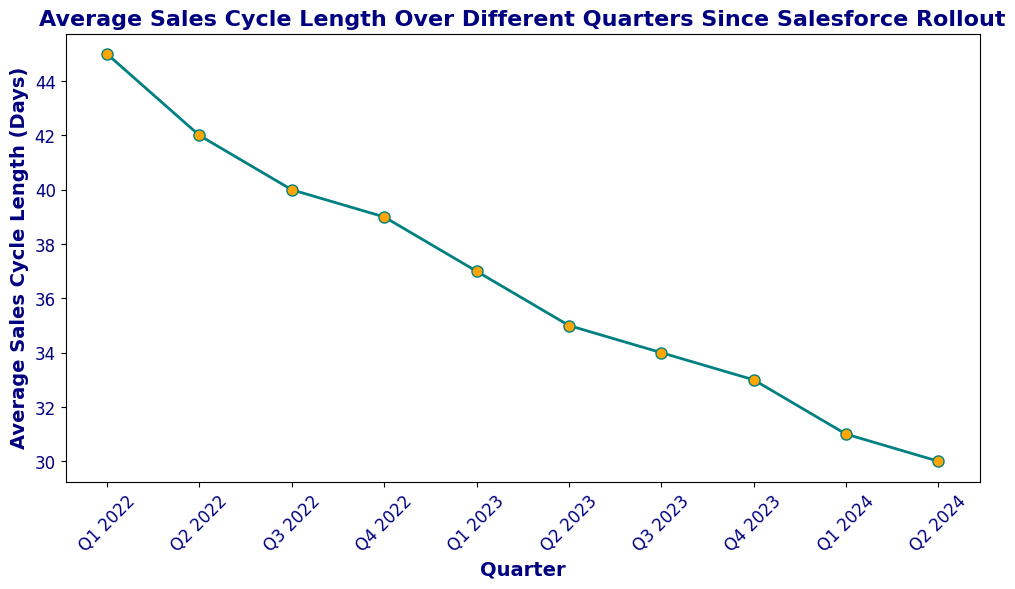What is the overall trend observed in the Average Sales Cycle Length from Q1 2022 to Q2 2024? The graph shows a continuously descending line from Q1 2022 to Q2 2024, indicating that the Average Sales Cycle Length has been steadily decreasing over time.
Answer: Steadily decreasing In which quarter was the largest drop in the Average Sales Cycle Length observed? The largest decrease can be observed between Q1 2022 and Q2 2022, where the Average Sales Cycle Length dropped from 45 days to 42 days, a change of 3 days.
Answer: Between Q1 2022 and Q2 2022 What is the difference in Average Sales Cycle Length between Q4 2022 and Q2 2024? The Average Sales Cycle Length is 39 days in Q4 2022 and 30 days in Q2 2024. Subtracting these gives a difference of 39 - 30 = 9 days.
Answer: 9 days What was the Average Sales Cycle Length in Q3 2023? According to the plot, the Average Sales Cycle Length in Q3 2023 was 34 days.
Answer: 34 days How much did the average sales cycle length decrease from Q2 2022 to Q4 2022? The length drops from 42 days in Q2 2022 to 39 days in Q4 2022. The decrease is 42 - 39 = 3 days.
Answer: 3 days If the trend continues, what would you expect the Average Sales Cycle Length to be in Q3 2024? Over the previous quarters, the average decrease per quarter is approximately 1-2 days. If we extrapolate this trend, we can estimate a continued decrease of 1-2 days from 30 days in Q2 2024, resulting in around 28-29 days in Q3 2024.
Answer: Around 28-29 days How many quarters saw a decrease of more than 2 days in the Average Sales Cycle Length? The quarters with a decrease of more than 2 days are between Q1 2022 and Q2 2022 (3 days), Q2 2022 and Q3 2022 (2 days), and Q1 2023 and Q2 2023 (2 days). That's 3 such quarters.
Answer: 3 quarters Was the decrease in Average Sales Cycle Length consistent throughout the periods shown? While the trend is consistently downward, the rate of decrease varies, with some quarters showing larger decreases (e.g., Q1 2022 to Q2 2022 at 3 days) and others smaller (e.g., Q3 2023 to Q4 2023 at 1 day).
Answer: No, it varied 